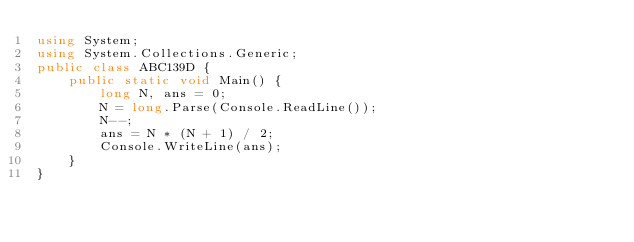Convert code to text. <code><loc_0><loc_0><loc_500><loc_500><_C#_>using System;
using System.Collections.Generic;
public class ABC139D {
    public static void Main() {
        long N, ans = 0;
        N = long.Parse(Console.ReadLine());
        N--;
        ans = N * (N + 1) / 2;
        Console.WriteLine(ans);
    }
}
</code> 